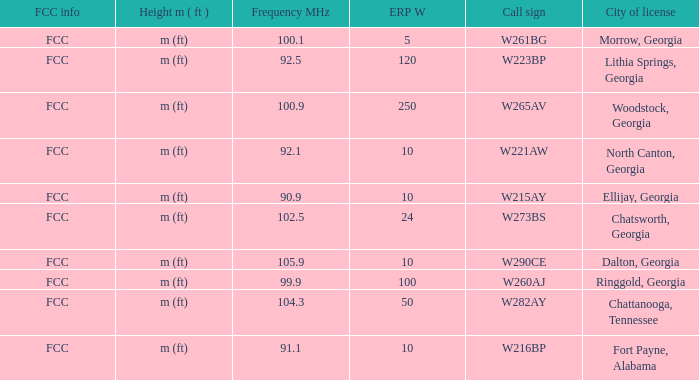What is the lowest ERP W of  w223bp? 120.0. 